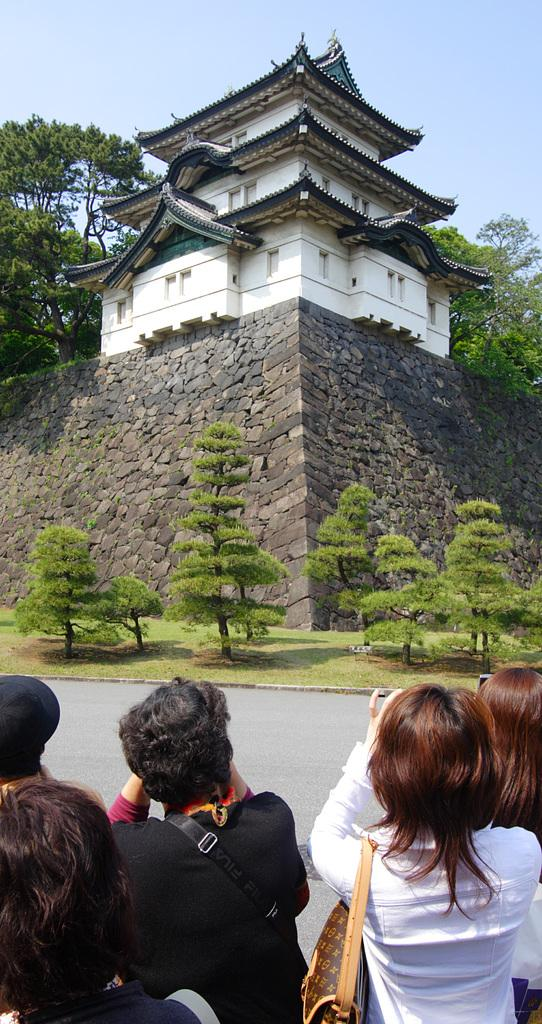What is the main structure in the center of the image? There is a building in the center of the image. What type of natural elements can be seen in the image? There are trees visible in the image. Who or what is located at the bottom of the image? There are people at the bottom of the image. What can be seen in the background of the image? The sky is visible in the background of the image. What type of art is displayed on the kettle in the image? There is no kettle present in the image, so it is not possible to determine what type of art might be displayed on it. 